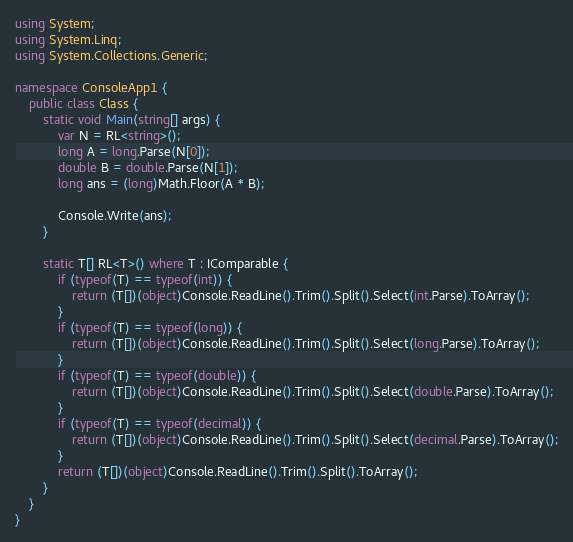Convert code to text. <code><loc_0><loc_0><loc_500><loc_500><_C#_>using System;
using System.Linq;
using System.Collections.Generic;

namespace ConsoleApp1 {
    public class Class {
        static void Main(string[] args) {
            var N = RL<string>();
            long A = long.Parse(N[0]);
            double B = double.Parse(N[1]);
            long ans = (long)Math.Floor(A * B); 

            Console.Write(ans);
        }

        static T[] RL<T>() where T : IComparable {
            if (typeof(T) == typeof(int)) {
                return (T[])(object)Console.ReadLine().Trim().Split().Select(int.Parse).ToArray();
            }
            if (typeof(T) == typeof(long)) {
                return (T[])(object)Console.ReadLine().Trim().Split().Select(long.Parse).ToArray();
            }
            if (typeof(T) == typeof(double)) {
                return (T[])(object)Console.ReadLine().Trim().Split().Select(double.Parse).ToArray();
            }
            if (typeof(T) == typeof(decimal)) {
                return (T[])(object)Console.ReadLine().Trim().Split().Select(decimal.Parse).ToArray();
            }
            return (T[])(object)Console.ReadLine().Trim().Split().ToArray();
        }
    }
}</code> 